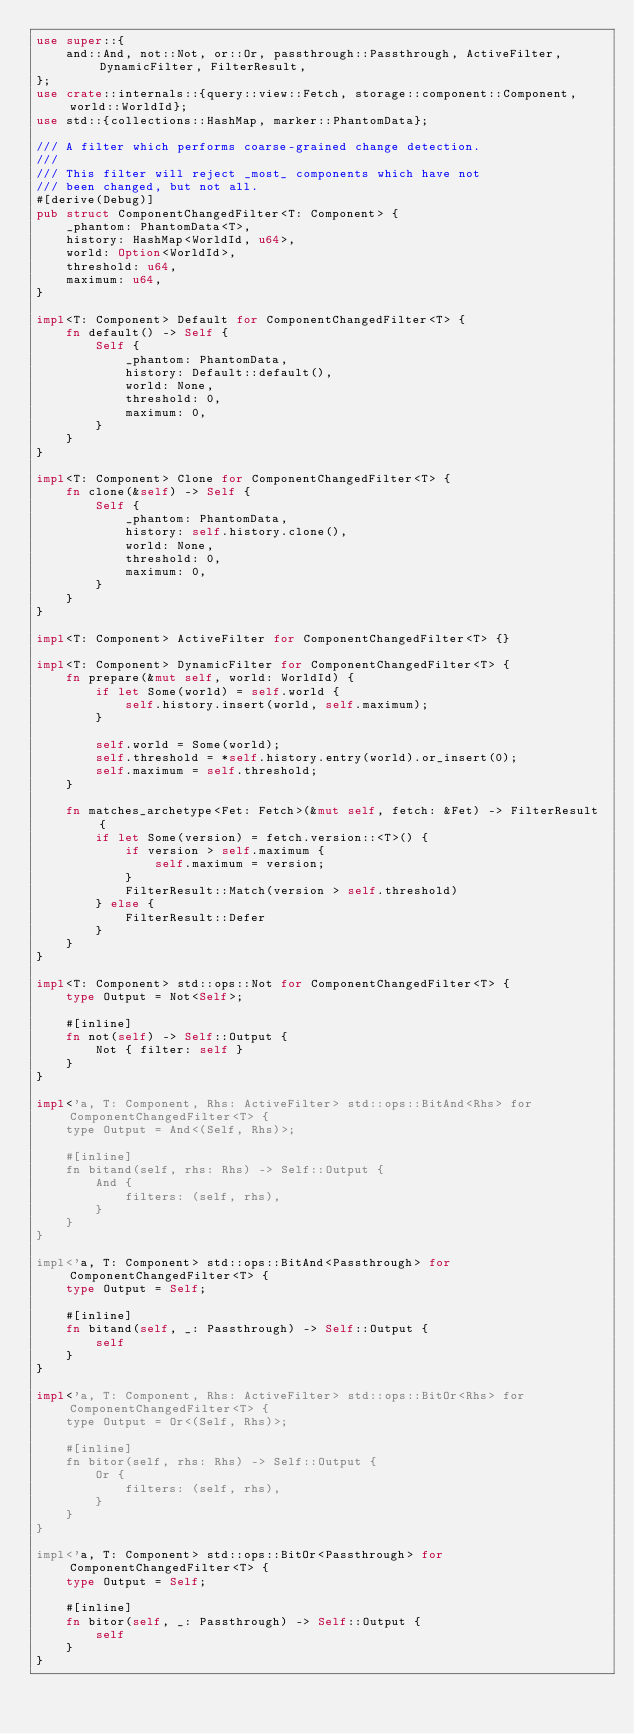Convert code to text. <code><loc_0><loc_0><loc_500><loc_500><_Rust_>use super::{
    and::And, not::Not, or::Or, passthrough::Passthrough, ActiveFilter, DynamicFilter, FilterResult,
};
use crate::internals::{query::view::Fetch, storage::component::Component, world::WorldId};
use std::{collections::HashMap, marker::PhantomData};

/// A filter which performs coarse-grained change detection.
///
/// This filter will reject _most_ components which have not
/// been changed, but not all.
#[derive(Debug)]
pub struct ComponentChangedFilter<T: Component> {
    _phantom: PhantomData<T>,
    history: HashMap<WorldId, u64>,
    world: Option<WorldId>,
    threshold: u64,
    maximum: u64,
}

impl<T: Component> Default for ComponentChangedFilter<T> {
    fn default() -> Self {
        Self {
            _phantom: PhantomData,
            history: Default::default(),
            world: None,
            threshold: 0,
            maximum: 0,
        }
    }
}

impl<T: Component> Clone for ComponentChangedFilter<T> {
    fn clone(&self) -> Self {
        Self {
            _phantom: PhantomData,
            history: self.history.clone(),
            world: None,
            threshold: 0,
            maximum: 0,
        }
    }
}

impl<T: Component> ActiveFilter for ComponentChangedFilter<T> {}

impl<T: Component> DynamicFilter for ComponentChangedFilter<T> {
    fn prepare(&mut self, world: WorldId) {
        if let Some(world) = self.world {
            self.history.insert(world, self.maximum);
        }

        self.world = Some(world);
        self.threshold = *self.history.entry(world).or_insert(0);
        self.maximum = self.threshold;
    }

    fn matches_archetype<Fet: Fetch>(&mut self, fetch: &Fet) -> FilterResult {
        if let Some(version) = fetch.version::<T>() {
            if version > self.maximum {
                self.maximum = version;
            }
            FilterResult::Match(version > self.threshold)
        } else {
            FilterResult::Defer
        }
    }
}

impl<T: Component> std::ops::Not for ComponentChangedFilter<T> {
    type Output = Not<Self>;

    #[inline]
    fn not(self) -> Self::Output {
        Not { filter: self }
    }
}

impl<'a, T: Component, Rhs: ActiveFilter> std::ops::BitAnd<Rhs> for ComponentChangedFilter<T> {
    type Output = And<(Self, Rhs)>;

    #[inline]
    fn bitand(self, rhs: Rhs) -> Self::Output {
        And {
            filters: (self, rhs),
        }
    }
}

impl<'a, T: Component> std::ops::BitAnd<Passthrough> for ComponentChangedFilter<T> {
    type Output = Self;

    #[inline]
    fn bitand(self, _: Passthrough) -> Self::Output {
        self
    }
}

impl<'a, T: Component, Rhs: ActiveFilter> std::ops::BitOr<Rhs> for ComponentChangedFilter<T> {
    type Output = Or<(Self, Rhs)>;

    #[inline]
    fn bitor(self, rhs: Rhs) -> Self::Output {
        Or {
            filters: (self, rhs),
        }
    }
}

impl<'a, T: Component> std::ops::BitOr<Passthrough> for ComponentChangedFilter<T> {
    type Output = Self;

    #[inline]
    fn bitor(self, _: Passthrough) -> Self::Output {
        self
    }
}
</code> 